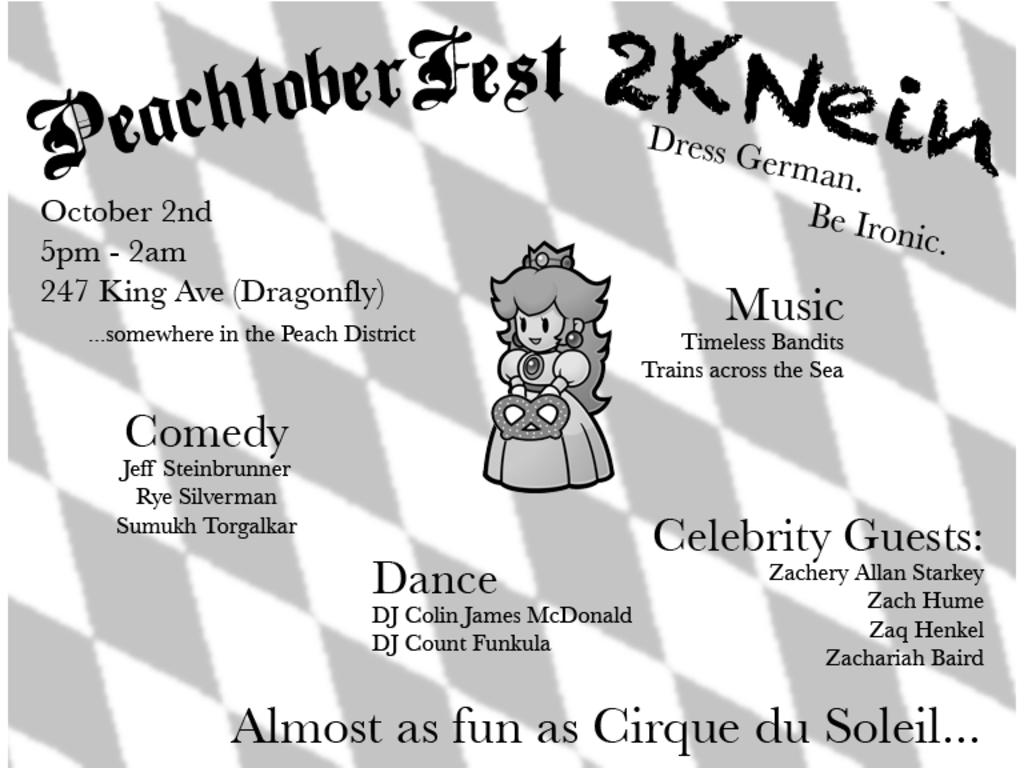What is present on the poster in the image? There is a poster in the image, which contains a cartoon picture. What type of image is depicted on the poster? The image on the poster is a cartoon picture. Is there any text on the poster? Yes, text is written on the poster. What type of bun is being used to solve the crime in the image? There is no bun or crime present in the image; it only features a poster with a cartoon picture and text. 